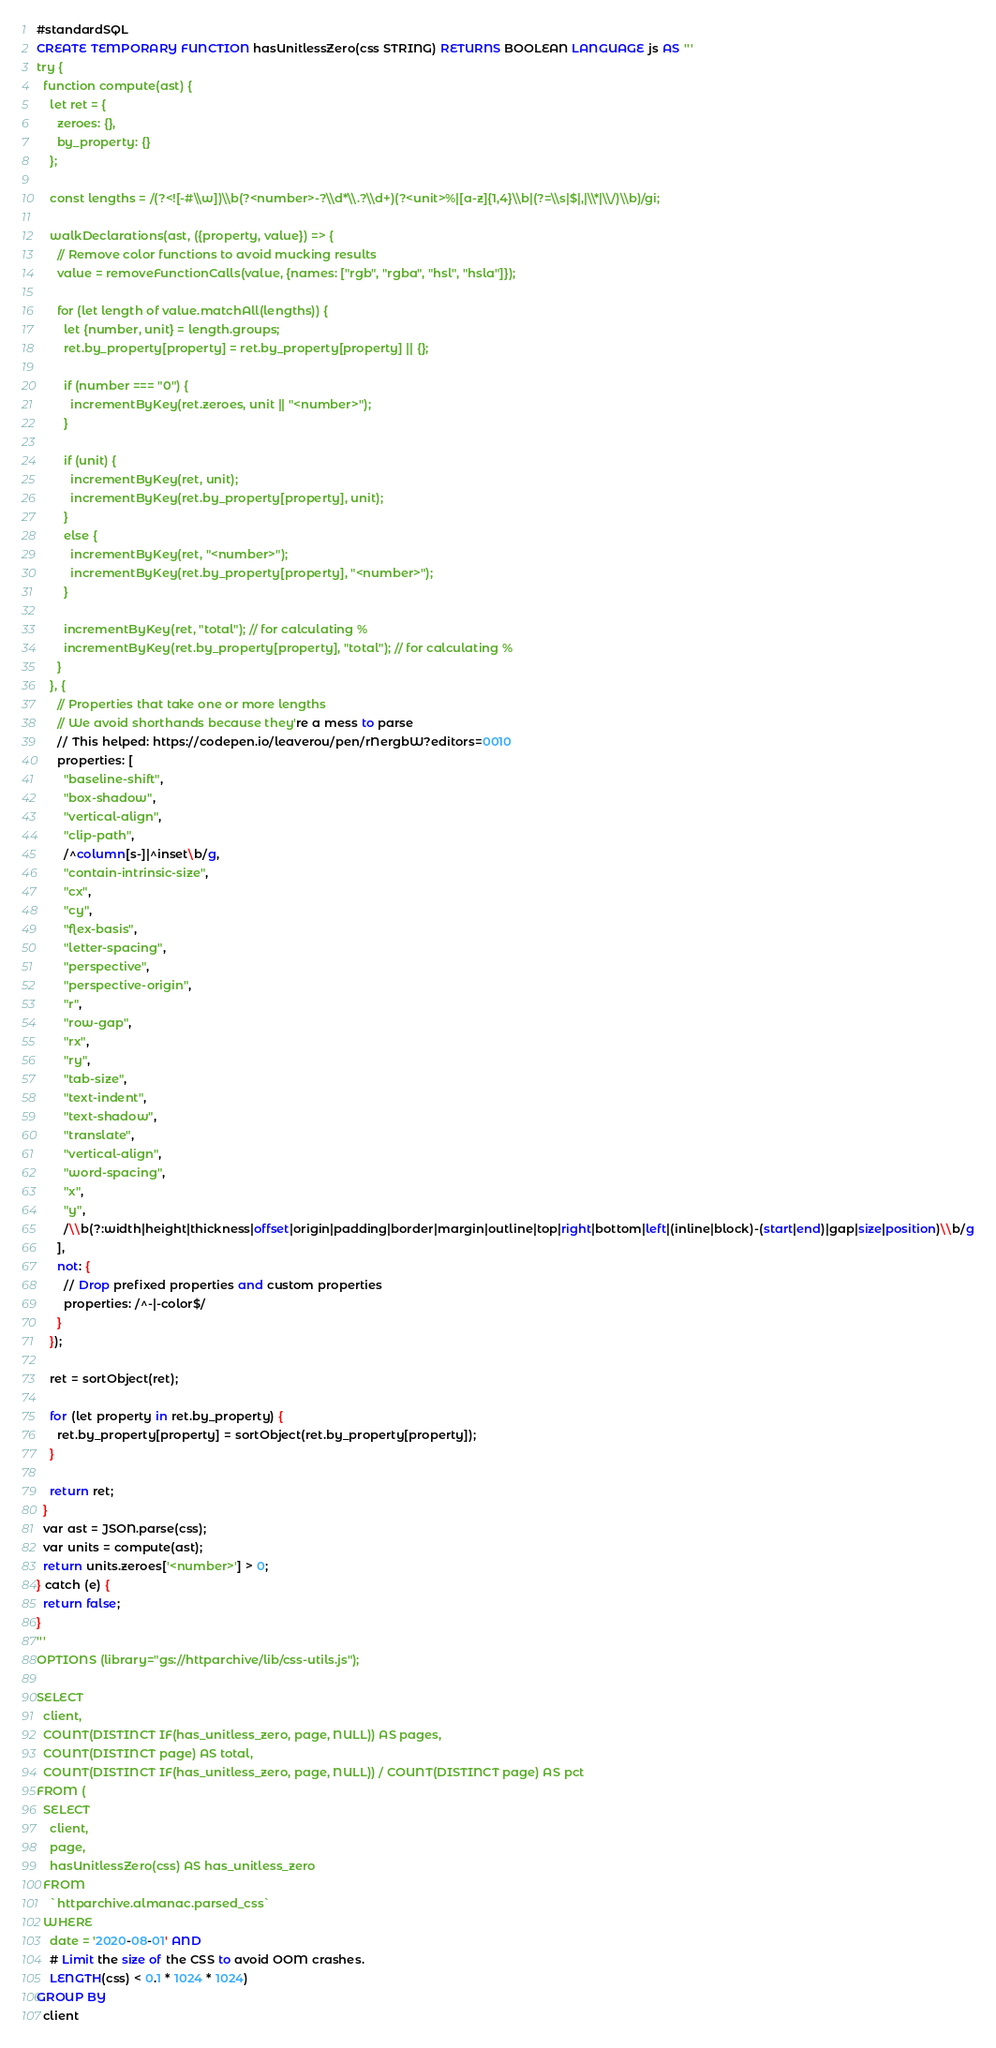<code> <loc_0><loc_0><loc_500><loc_500><_SQL_>#standardSQL
CREATE TEMPORARY FUNCTION hasUnitlessZero(css STRING) RETURNS BOOLEAN LANGUAGE js AS '''
try {
  function compute(ast) {
    let ret = {
      zeroes: {},
      by_property: {}
    };

    const lengths = /(?<![-#\\w])\\b(?<number>-?\\d*\\.?\\d+)(?<unit>%|[a-z]{1,4}\\b|(?=\\s|$|,|\\*|\\/)\\b)/gi;

    walkDeclarations(ast, ({property, value}) => {
      // Remove color functions to avoid mucking results
      value = removeFunctionCalls(value, {names: ["rgb", "rgba", "hsl", "hsla"]});

      for (let length of value.matchAll(lengths)) {
        let {number, unit} = length.groups;
        ret.by_property[property] = ret.by_property[property] || {};

        if (number === "0") {
          incrementByKey(ret.zeroes, unit || "<number>");
        }

        if (unit) {
          incrementByKey(ret, unit);
          incrementByKey(ret.by_property[property], unit);
        }
        else {
          incrementByKey(ret, "<number>");
          incrementByKey(ret.by_property[property], "<number>");
        }

        incrementByKey(ret, "total"); // for calculating %
        incrementByKey(ret.by_property[property], "total"); // for calculating %
      }
    }, {
      // Properties that take one or more lengths
      // We avoid shorthands because they're a mess to parse
      // This helped: https://codepen.io/leaverou/pen/rNergbW?editors=0010
      properties: [
        "baseline-shift",
        "box-shadow",
        "vertical-align",
        "clip-path",
        /^column[s-]|^inset\b/g,
        "contain-intrinsic-size",
        "cx",
        "cy",
        "flex-basis",
        "letter-spacing",
        "perspective",
        "perspective-origin",
        "r",
        "row-gap",
        "rx",
        "ry",
        "tab-size",
        "text-indent",
        "text-shadow",
        "translate",
        "vertical-align",
        "word-spacing",
        "x",
        "y",
        /\\b(?:width|height|thickness|offset|origin|padding|border|margin|outline|top|right|bottom|left|(inline|block)-(start|end)|gap|size|position)\\b/g
      ],
      not: {
        // Drop prefixed properties and custom properties
        properties: /^-|-color$/
      }
    });

    ret = sortObject(ret);

    for (let property in ret.by_property) {
      ret.by_property[property] = sortObject(ret.by_property[property]);
    }

    return ret;
  }
  var ast = JSON.parse(css);
  var units = compute(ast);
  return units.zeroes['<number>'] > 0;
} catch (e) {
  return false;
}
'''
OPTIONS (library="gs://httparchive/lib/css-utils.js");

SELECT
  client,
  COUNT(DISTINCT IF(has_unitless_zero, page, NULL)) AS pages,
  COUNT(DISTINCT page) AS total,
  COUNT(DISTINCT IF(has_unitless_zero, page, NULL)) / COUNT(DISTINCT page) AS pct
FROM (
  SELECT
    client,
    page,
    hasUnitlessZero(css) AS has_unitless_zero
  FROM
    `httparchive.almanac.parsed_css`
  WHERE
    date = '2020-08-01' AND
    # Limit the size of the CSS to avoid OOM crashes.
    LENGTH(css) < 0.1 * 1024 * 1024)
GROUP BY
  client</code> 